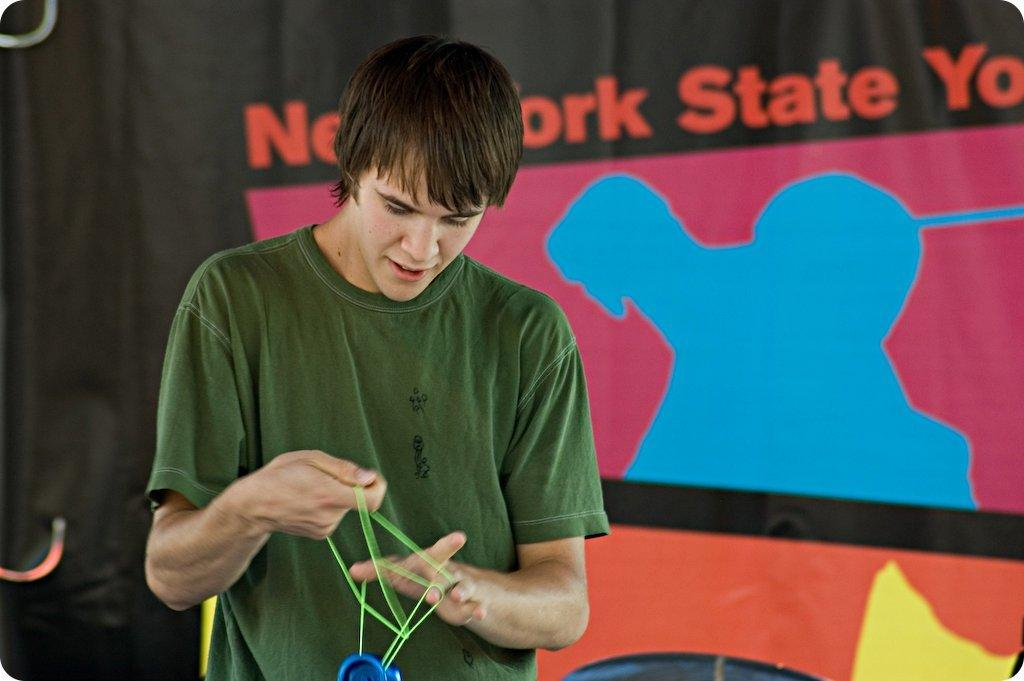What is the main subject in the front of the image? There is a man standing in the front of the image. What is the man holding in the image? The man is holding an object that is green and blue in color. What can be seen in the background of the image? There is a banner in the background of the image. What information is provided on the banner? The banner has text written on it. What type of instrument does the man fear in the image? There is no instrument or fear present in the image; it only features a man holding a green and blue object and a banner in the background. 